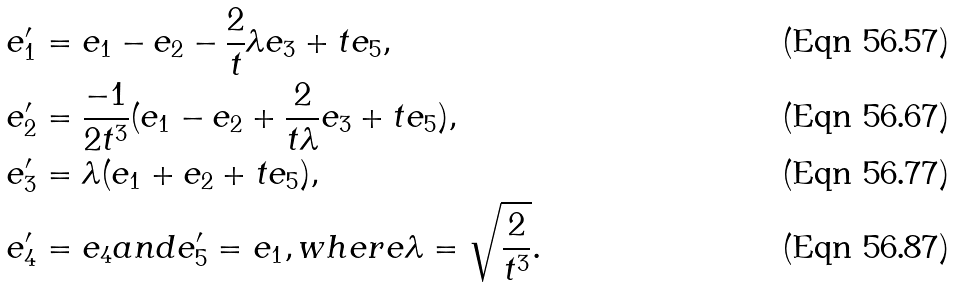<formula> <loc_0><loc_0><loc_500><loc_500>& e ^ { \prime } _ { 1 } = e _ { 1 } - e _ { 2 } - \frac { 2 } { t } \lambda e _ { 3 } + t e _ { 5 } , \\ & e ^ { \prime } _ { 2 } = \frac { - 1 } { 2 t ^ { 3 } } ( e _ { 1 } - e _ { 2 } + \frac { 2 } { t \lambda } e _ { 3 } + t e _ { 5 } ) , \\ & e ^ { \prime } _ { 3 } = \lambda ( e _ { 1 } + e _ { 2 } + t e _ { 5 } ) , \\ & e ^ { \prime } _ { 4 } = e _ { 4 } a n d e _ { 5 } ^ { \prime } = e _ { 1 } , w h e r e \lambda = \sqrt { \frac { 2 } { t ^ { 3 } } } .</formula> 